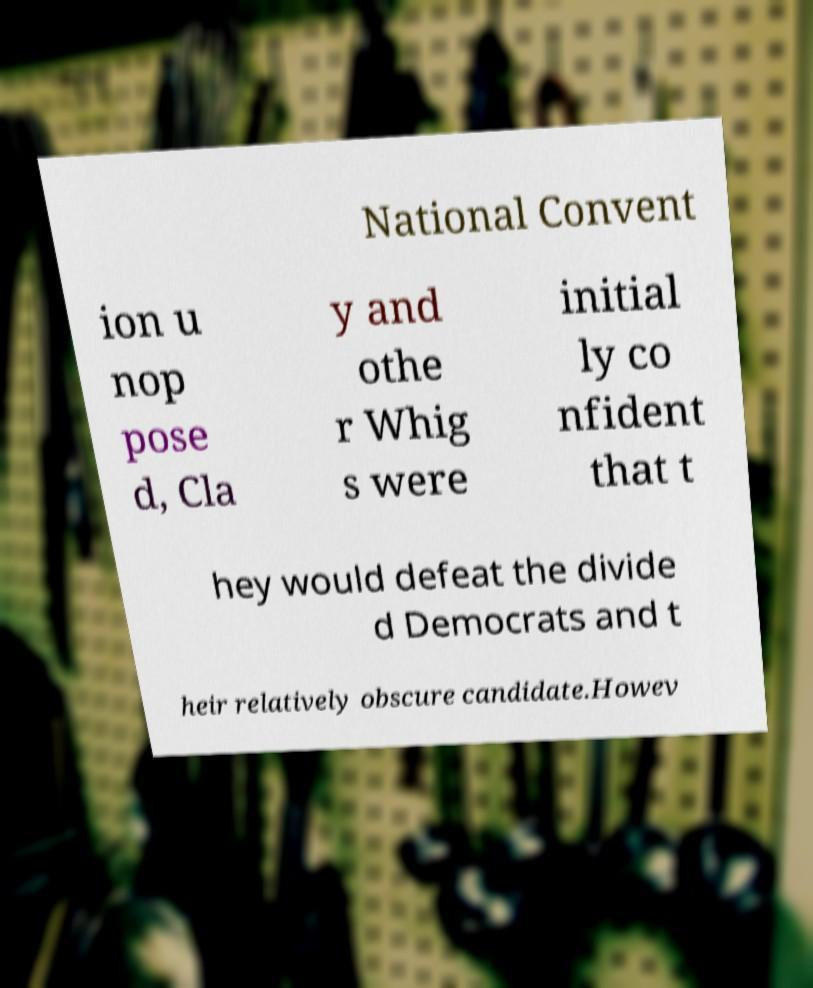What messages or text are displayed in this image? I need them in a readable, typed format. National Convent ion u nop pose d, Cla y and othe r Whig s were initial ly co nfident that t hey would defeat the divide d Democrats and t heir relatively obscure candidate.Howev 